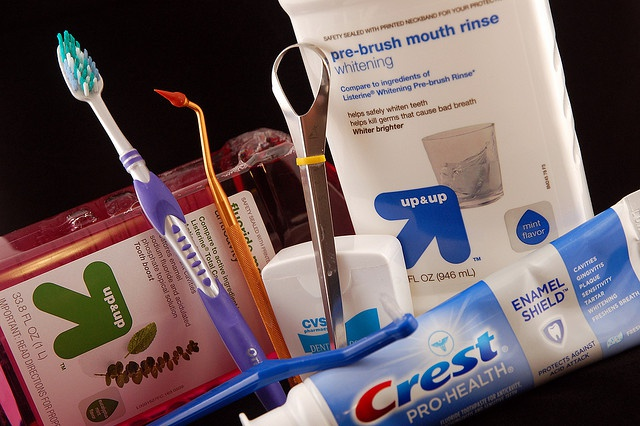Describe the objects in this image and their specific colors. I can see toothbrush in black, purple, darkgray, and lightgray tones and toothbrush in black, navy, blue, darkblue, and gray tones in this image. 